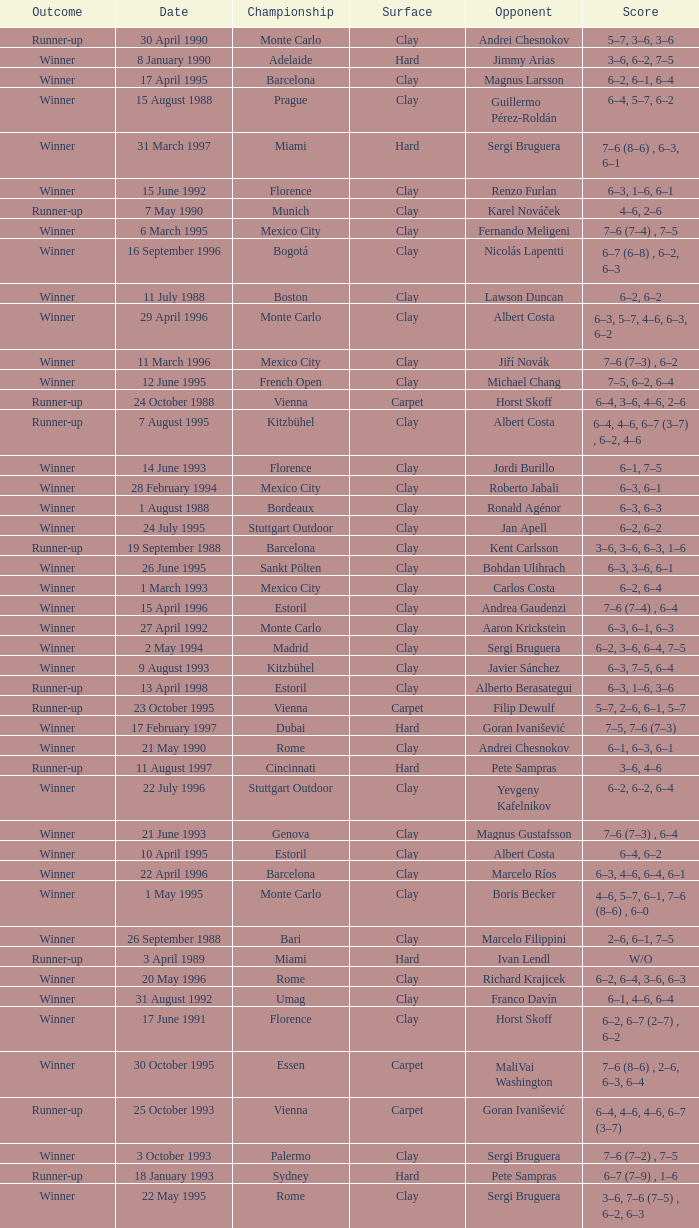Who is the opponent when the surface is clay, the outcome is winner and the championship is estoril on 15 april 1996? Andrea Gaudenzi. 